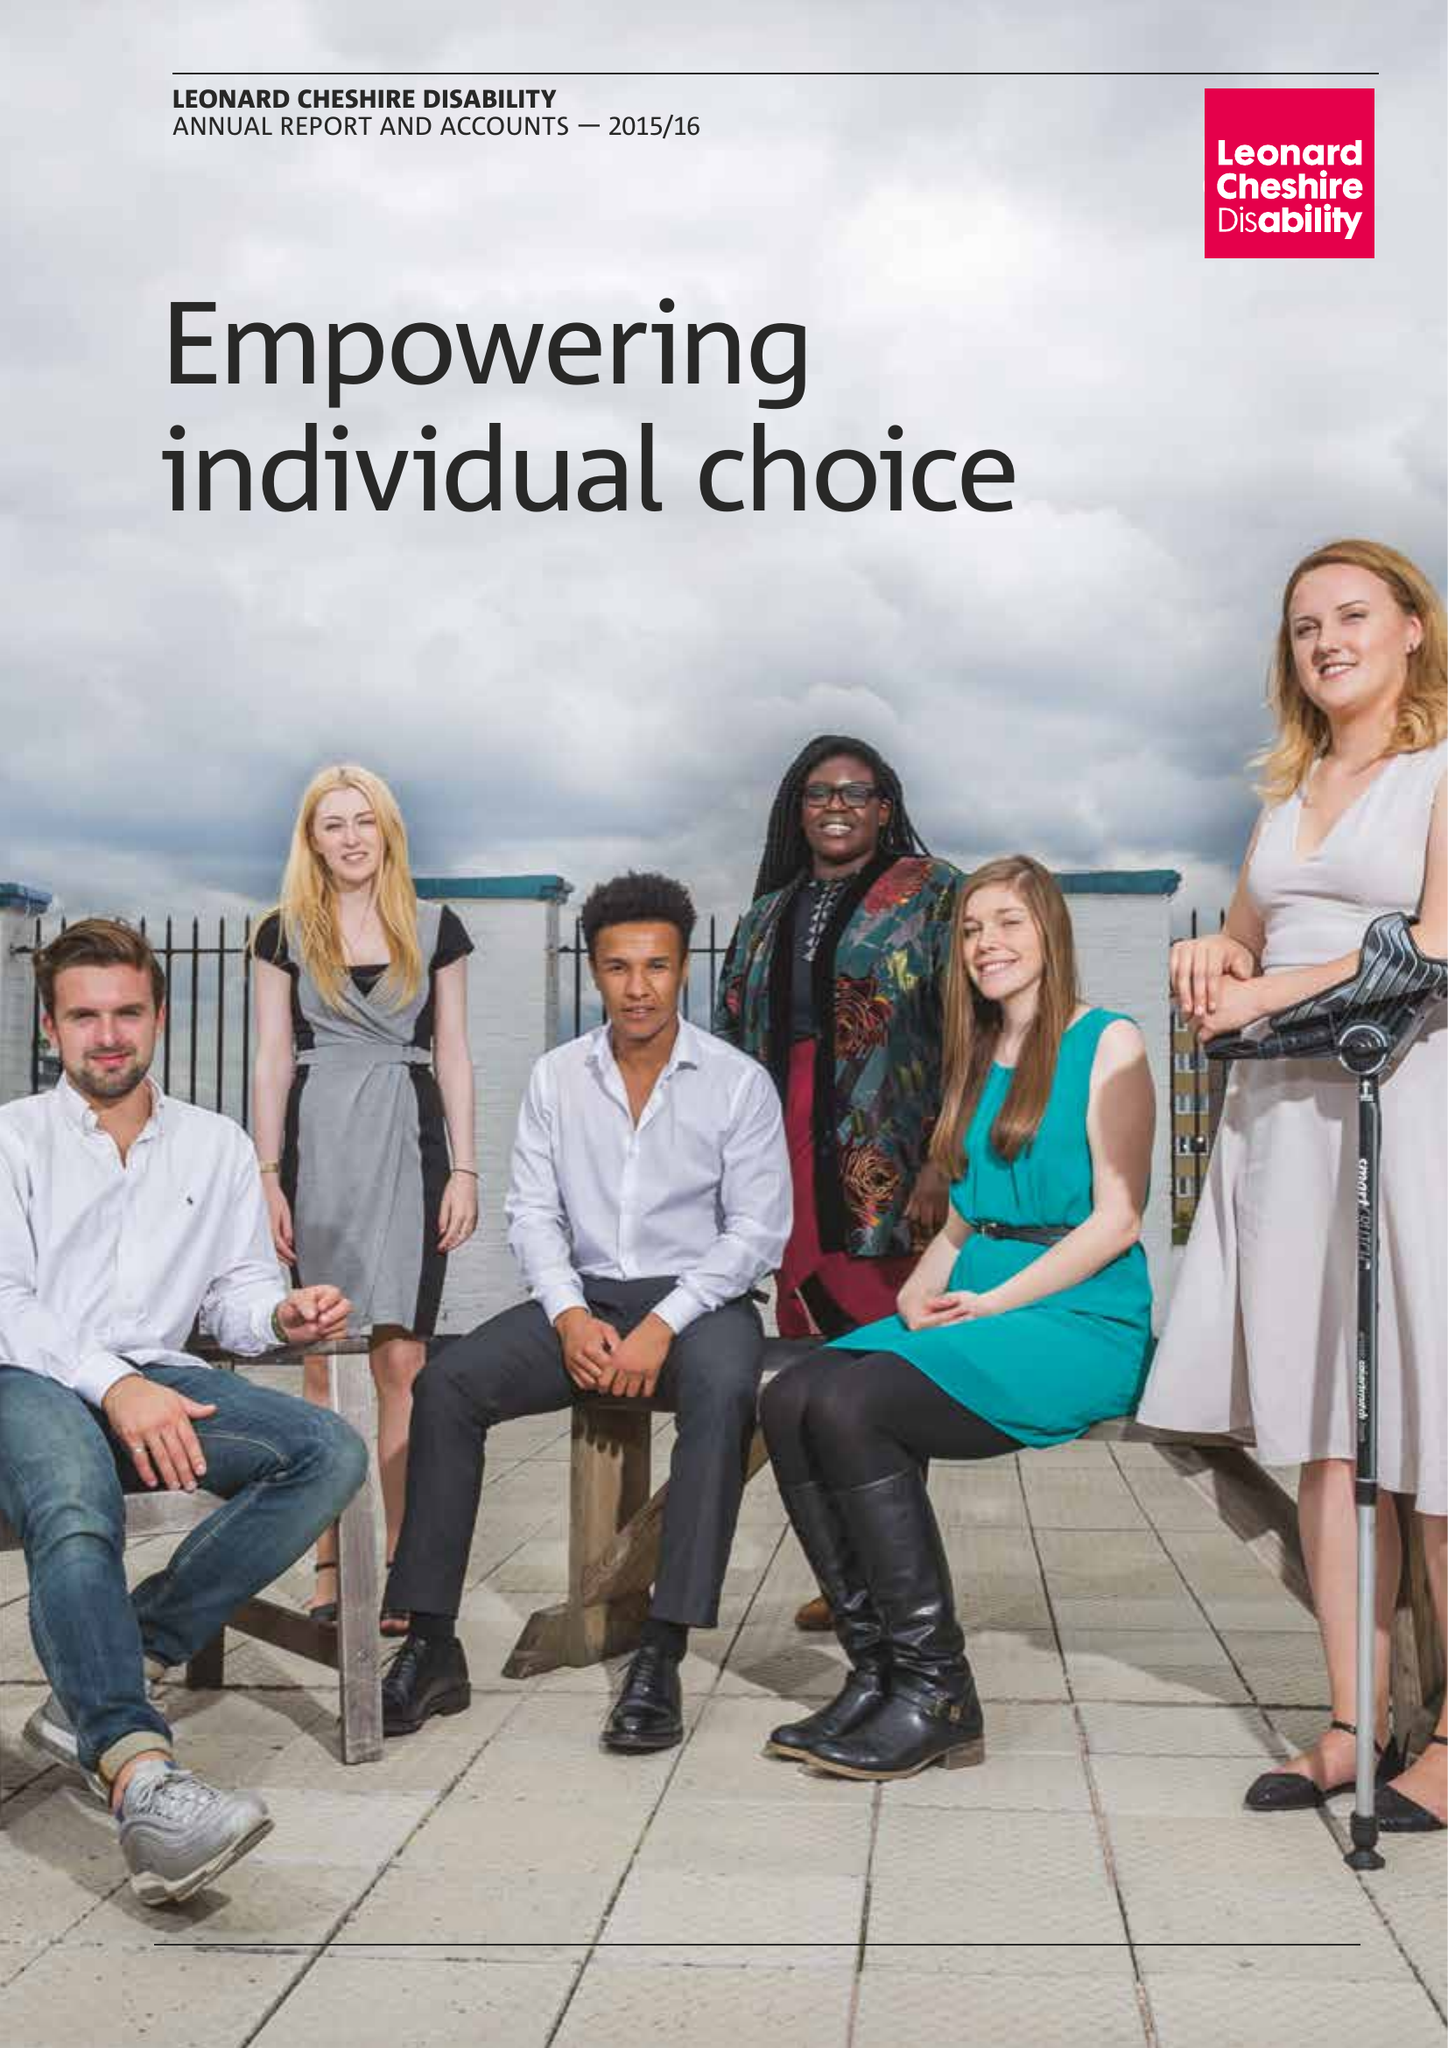What is the value for the address__post_town?
Answer the question using a single word or phrase. LONDON 